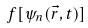Convert formula to latex. <formula><loc_0><loc_0><loc_500><loc_500>f [ \psi _ { n } ( { \vec { r } } , t ) ]</formula> 